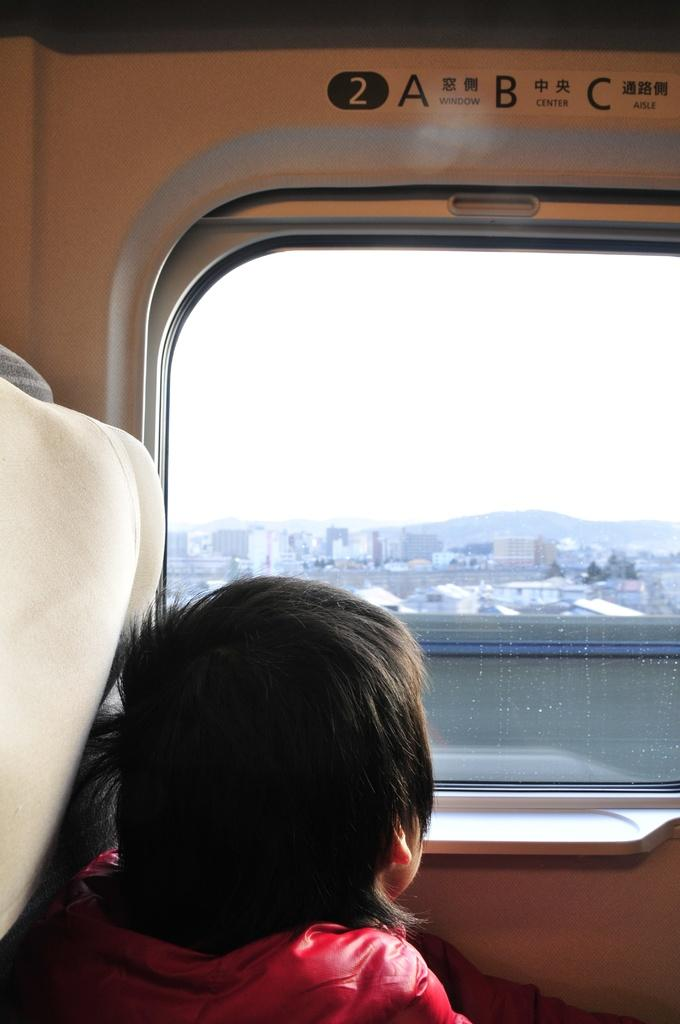What is the main subject in the foreground of the image? There is a kid in the foreground of the image. What is the kid doing in the image? The kid is sitting on a seat. What is the kid looking at through the glass window? The kid is looking through a glass window that provides a view of the city. What can be seen in the sky through the glass window? The sky is visible through the glass window. What type of rings can be seen on the kid's fingers in the image? There are no rings visible on the kid's fingers in the image. What type of produce is being sold in the city view through the glass window? There is no produce visible in the city view through the glass window in the image. 